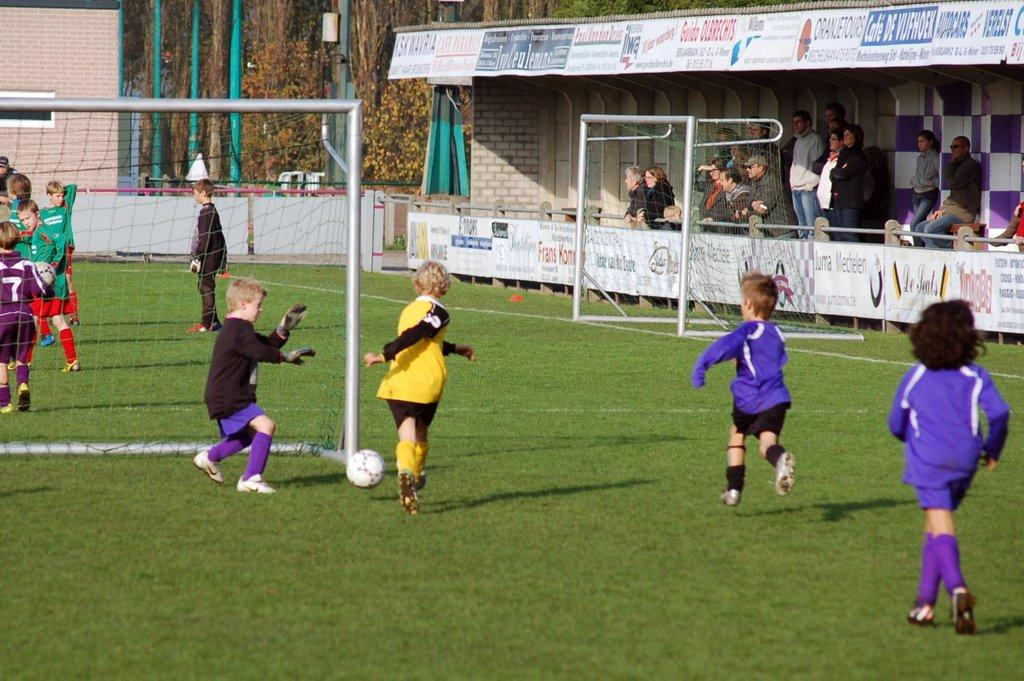<image>
Present a compact description of the photo's key features. A boy in a purple soccer uniform with number 7 stands behind the goal. 